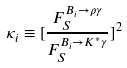<formula> <loc_0><loc_0><loc_500><loc_500>\kappa _ { i } \equiv [ \frac { F _ { S } ^ { B _ { i } \to \rho \gamma } } { F _ { S } ^ { B _ { i } \to K ^ { * } \gamma } } ] ^ { 2 }</formula> 